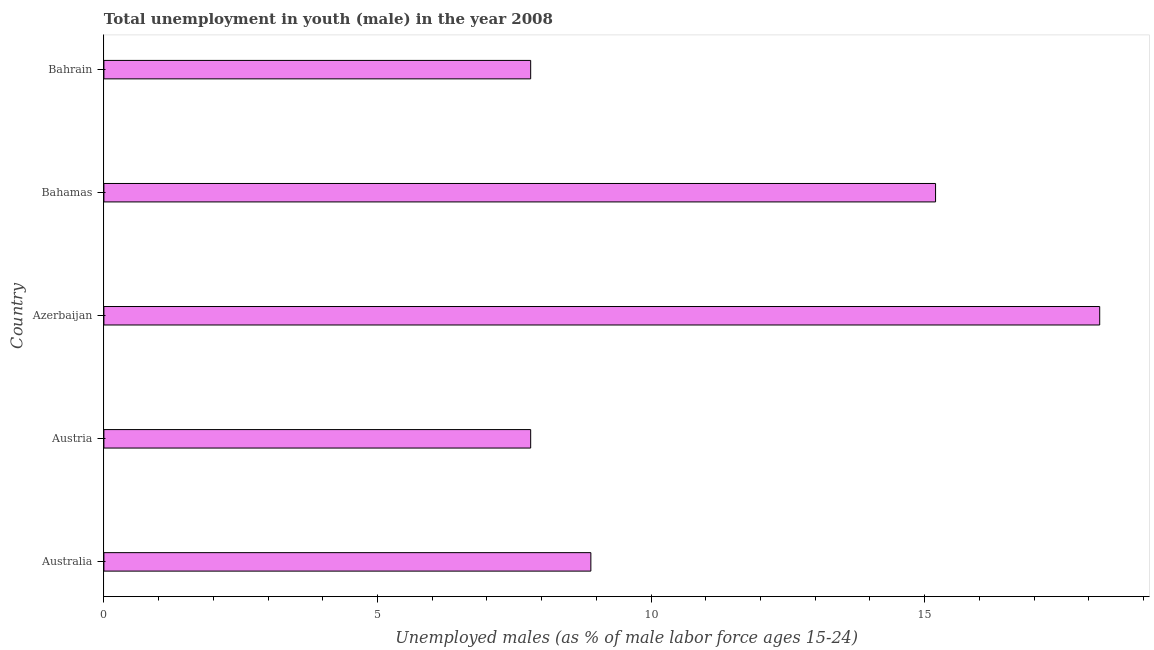Does the graph contain any zero values?
Make the answer very short. No. Does the graph contain grids?
Make the answer very short. No. What is the title of the graph?
Ensure brevity in your answer.  Total unemployment in youth (male) in the year 2008. What is the label or title of the X-axis?
Ensure brevity in your answer.  Unemployed males (as % of male labor force ages 15-24). What is the label or title of the Y-axis?
Make the answer very short. Country. What is the unemployed male youth population in Bahrain?
Offer a terse response. 7.8. Across all countries, what is the maximum unemployed male youth population?
Your response must be concise. 18.2. Across all countries, what is the minimum unemployed male youth population?
Offer a terse response. 7.8. In which country was the unemployed male youth population maximum?
Offer a terse response. Azerbaijan. In which country was the unemployed male youth population minimum?
Offer a very short reply. Austria. What is the sum of the unemployed male youth population?
Provide a succinct answer. 57.9. What is the difference between the unemployed male youth population in Azerbaijan and Bahamas?
Your response must be concise. 3. What is the average unemployed male youth population per country?
Your response must be concise. 11.58. What is the median unemployed male youth population?
Your answer should be very brief. 8.9. What is the ratio of the unemployed male youth population in Australia to that in Bahamas?
Your answer should be very brief. 0.59. What is the difference between the highest and the second highest unemployed male youth population?
Your answer should be compact. 3. Is the sum of the unemployed male youth population in Austria and Bahamas greater than the maximum unemployed male youth population across all countries?
Ensure brevity in your answer.  Yes. What is the difference between the highest and the lowest unemployed male youth population?
Make the answer very short. 10.4. In how many countries, is the unemployed male youth population greater than the average unemployed male youth population taken over all countries?
Offer a very short reply. 2. How many bars are there?
Keep it short and to the point. 5. Are all the bars in the graph horizontal?
Offer a very short reply. Yes. How many countries are there in the graph?
Give a very brief answer. 5. What is the difference between two consecutive major ticks on the X-axis?
Your response must be concise. 5. Are the values on the major ticks of X-axis written in scientific E-notation?
Provide a succinct answer. No. What is the Unemployed males (as % of male labor force ages 15-24) of Australia?
Your answer should be compact. 8.9. What is the Unemployed males (as % of male labor force ages 15-24) of Austria?
Ensure brevity in your answer.  7.8. What is the Unemployed males (as % of male labor force ages 15-24) of Azerbaijan?
Give a very brief answer. 18.2. What is the Unemployed males (as % of male labor force ages 15-24) of Bahamas?
Your response must be concise. 15.2. What is the Unemployed males (as % of male labor force ages 15-24) of Bahrain?
Offer a terse response. 7.8. What is the difference between the Unemployed males (as % of male labor force ages 15-24) in Austria and Bahamas?
Make the answer very short. -7.4. What is the difference between the Unemployed males (as % of male labor force ages 15-24) in Azerbaijan and Bahamas?
Offer a terse response. 3. What is the difference between the Unemployed males (as % of male labor force ages 15-24) in Bahamas and Bahrain?
Offer a terse response. 7.4. What is the ratio of the Unemployed males (as % of male labor force ages 15-24) in Australia to that in Austria?
Provide a succinct answer. 1.14. What is the ratio of the Unemployed males (as % of male labor force ages 15-24) in Australia to that in Azerbaijan?
Make the answer very short. 0.49. What is the ratio of the Unemployed males (as % of male labor force ages 15-24) in Australia to that in Bahamas?
Provide a short and direct response. 0.59. What is the ratio of the Unemployed males (as % of male labor force ages 15-24) in Australia to that in Bahrain?
Your answer should be compact. 1.14. What is the ratio of the Unemployed males (as % of male labor force ages 15-24) in Austria to that in Azerbaijan?
Provide a short and direct response. 0.43. What is the ratio of the Unemployed males (as % of male labor force ages 15-24) in Austria to that in Bahamas?
Offer a very short reply. 0.51. What is the ratio of the Unemployed males (as % of male labor force ages 15-24) in Austria to that in Bahrain?
Provide a short and direct response. 1. What is the ratio of the Unemployed males (as % of male labor force ages 15-24) in Azerbaijan to that in Bahamas?
Make the answer very short. 1.2. What is the ratio of the Unemployed males (as % of male labor force ages 15-24) in Azerbaijan to that in Bahrain?
Ensure brevity in your answer.  2.33. What is the ratio of the Unemployed males (as % of male labor force ages 15-24) in Bahamas to that in Bahrain?
Provide a succinct answer. 1.95. 